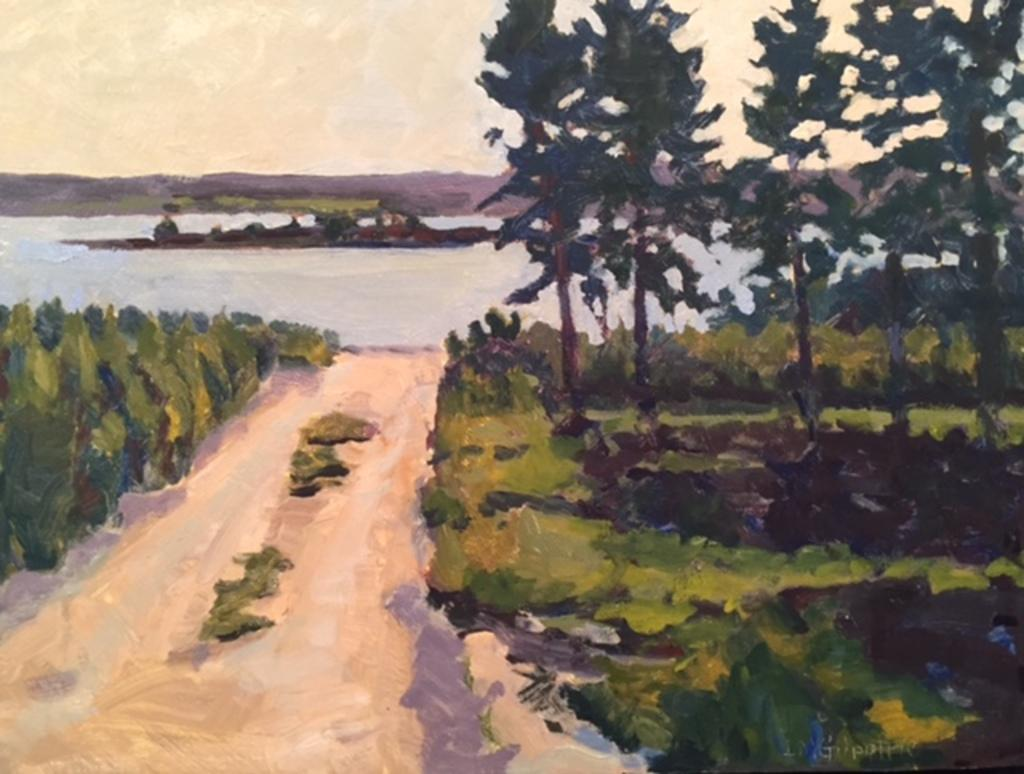What type of artwork is depicted in the image? The image is a painting. What is the main subject of the painting? There is a road in the painting. What can be seen on the sides of the road? There are trees on the sides of the road. What is visible in the background of the painting? Water and the sky are visible in the background of the painting. What type of wine is being served at the table in the painting? There is no table or wine present in the painting; it features a road with trees on the sides and water and sky in the background. What type of seed is growing on the side of the road in the painting? There is no seed visible in the painting; it features a road with trees on the sides and water and sky in the background. 